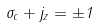Convert formula to latex. <formula><loc_0><loc_0><loc_500><loc_500>\sigma _ { c } + j _ { z } = \pm 1</formula> 